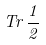<formula> <loc_0><loc_0><loc_500><loc_500>T r \, \frac { 1 } { 2 }</formula> 